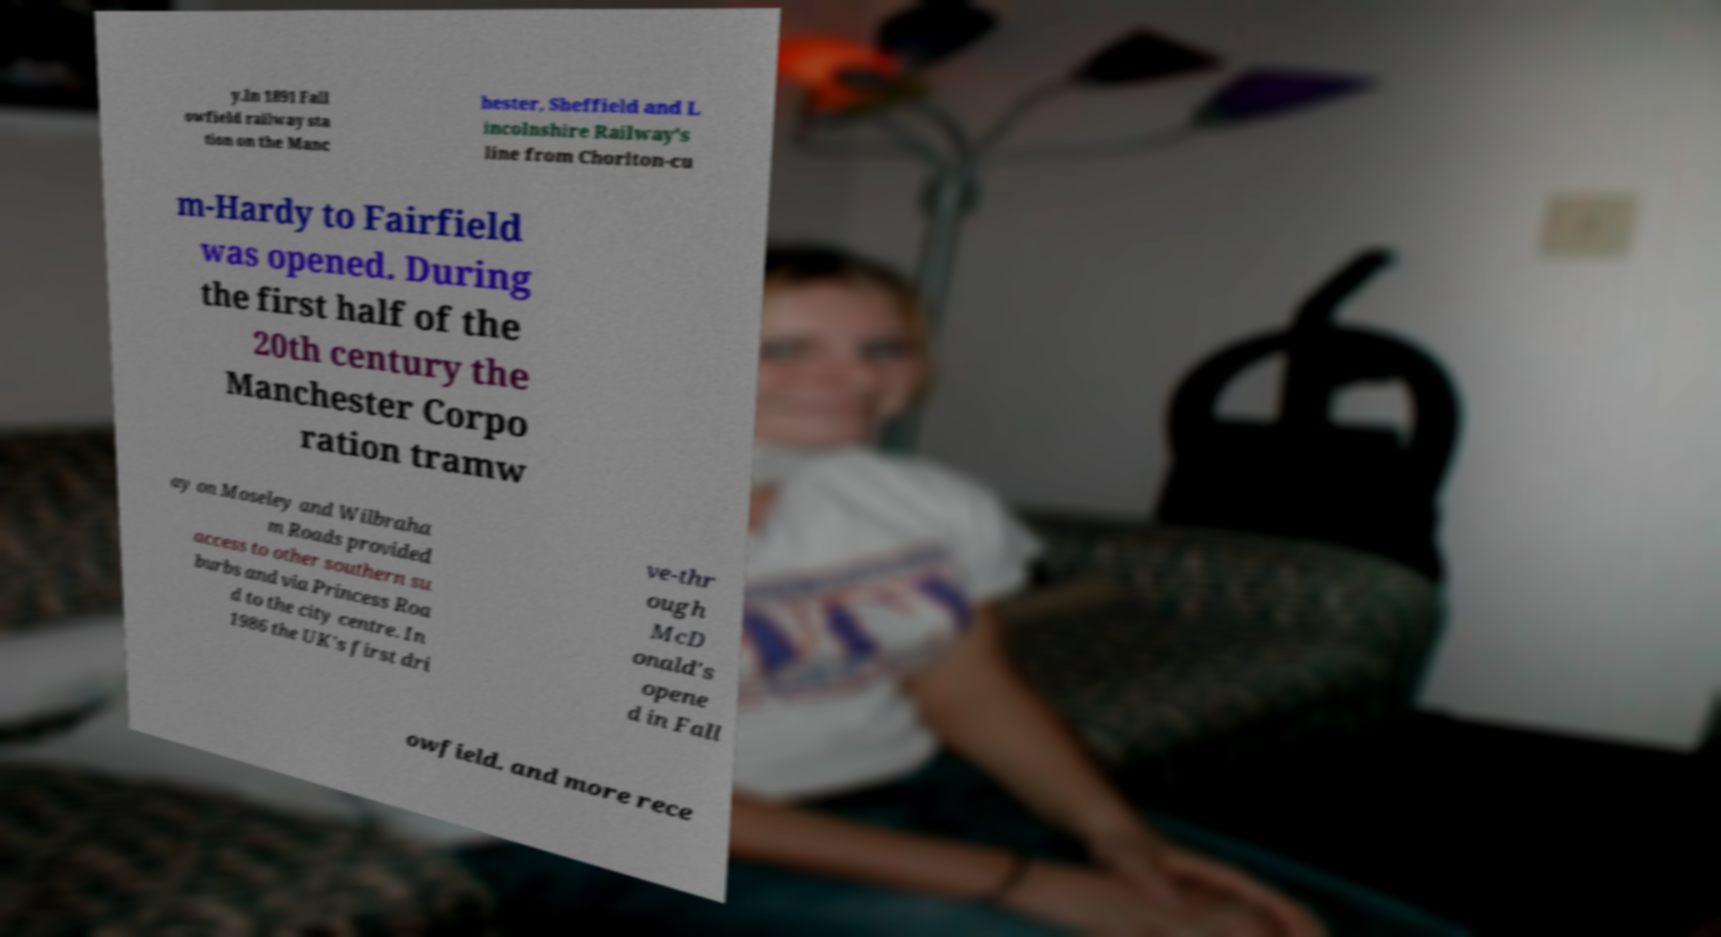Please identify and transcribe the text found in this image. y.In 1891 Fall owfield railway sta tion on the Manc hester, Sheffield and L incolnshire Railway's line from Chorlton-cu m-Hardy to Fairfield was opened. During the first half of the 20th century the Manchester Corpo ration tramw ay on Moseley and Wilbraha m Roads provided access to other southern su burbs and via Princess Roa d to the city centre. In 1986 the UK's first dri ve-thr ough McD onald's opene d in Fall owfield. and more rece 